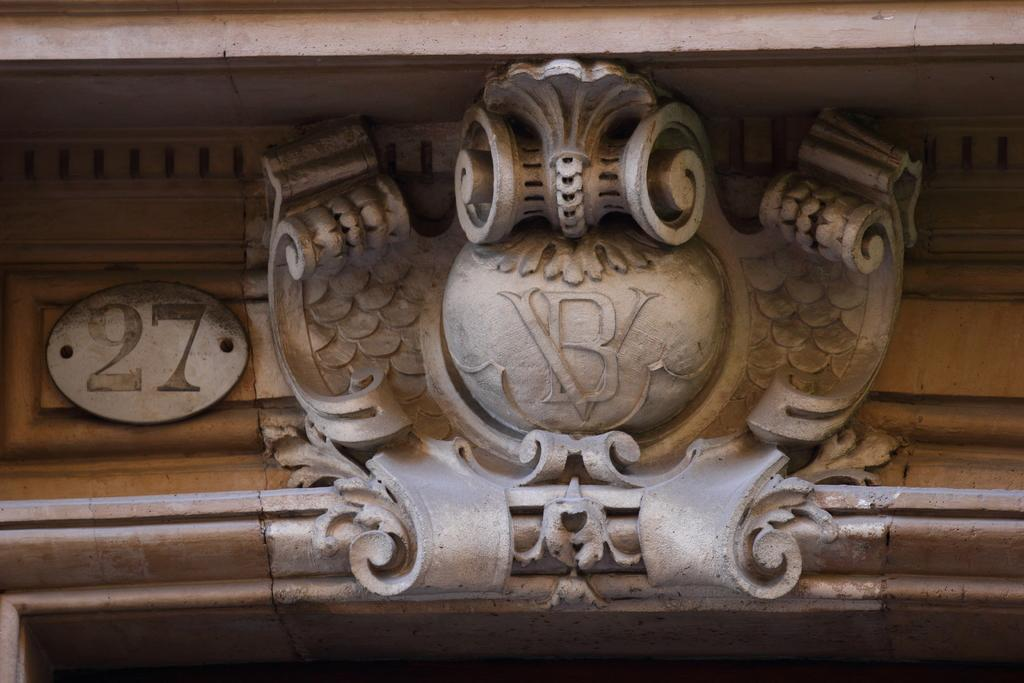What is the main subject of the image? The main subject of the image is sculptures of objects in the center. Can you describe the object on the left side of the image? There are numbers on an object on the left side of the image. What letter can be seen on the sculpture of the object in the center of the image? There is no letter visible on the sculpture of the object in the center of the image. 